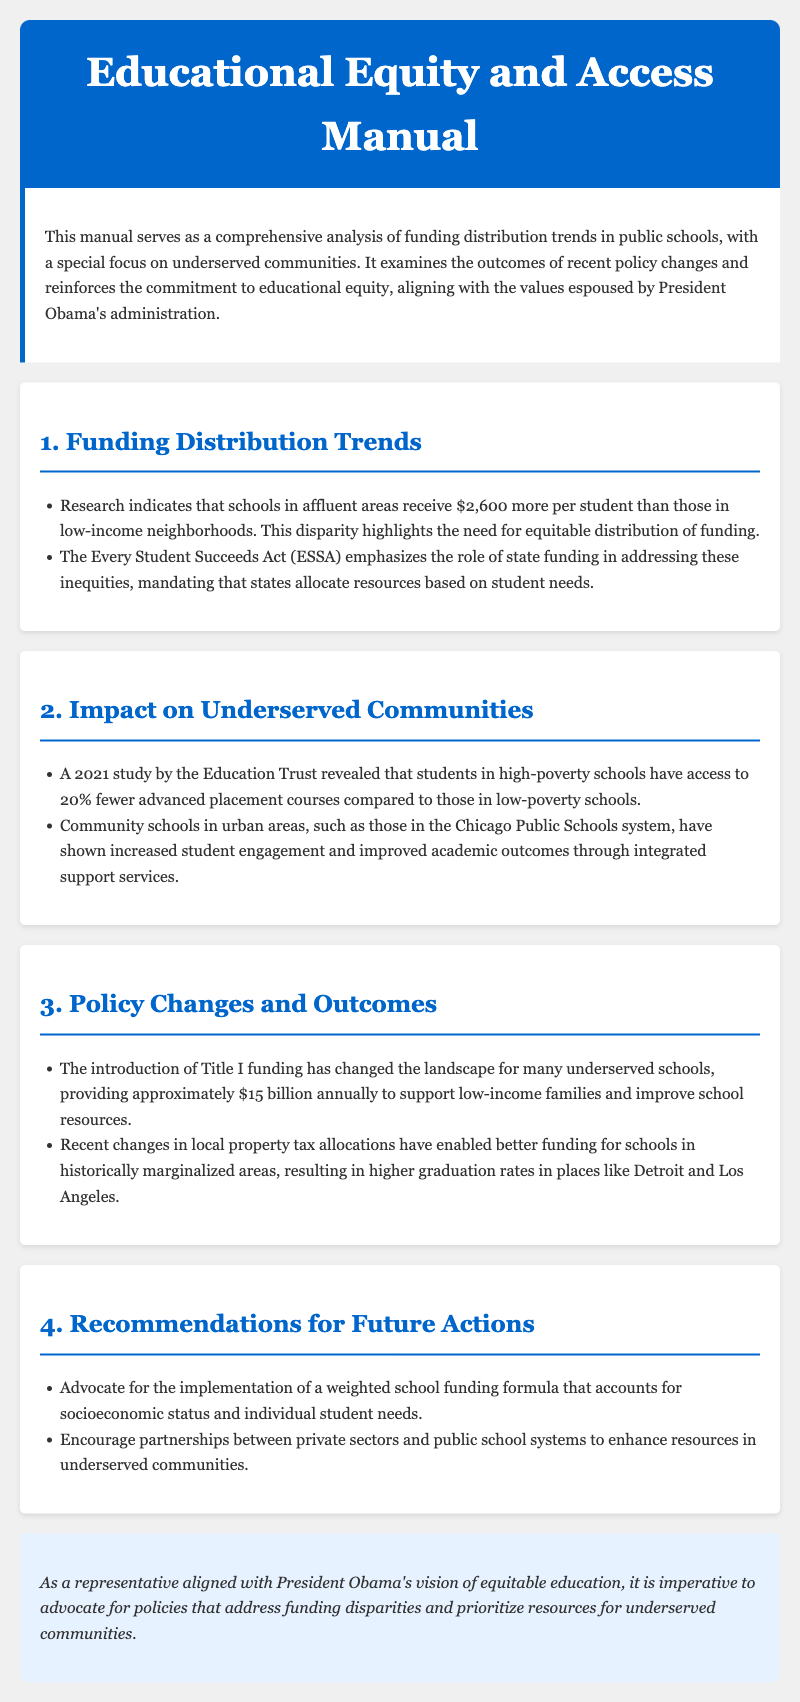What is the funding disparity per student in affluent areas? The document states that schools in affluent areas receive $2,600 more per student than those in low-income neighborhoods.
Answer: $2,600 What does ESSA emphasize? The Every Student Succeeds Act (ESSA) emphasizes the role of state funding in addressing inequities in education.
Answer: State funding What percentage fewer advanced placement courses do students in high-poverty schools have? A study revealed that students in high-poverty schools have access to 20% fewer advanced placement courses compared to those in low-poverty schools.
Answer: 20% How much does Title I funding provide annually? The document mentions that Title I funding provides approximately $15 billion annually to support low-income families and improve school resources.
Answer: $15 billion What notable city is mentioned regarding community schools improving academic outcomes? The document highlights the impact of community schools in urban areas, specifically in the Chicago Public Schools system.
Answer: Chicago What is a key recommendation for future actions regarding school funding? A key recommendation is to advocate for the implementation of a weighted school funding formula that accounts for socioeconomic status and individual student needs.
Answer: Weighted school funding formula How have recent changes in local property tax allocations affected schools? The document states that recent changes in local property tax allocations have enabled better funding for schools in historically marginalized areas.
Answer: Better funding What is the primary focus of this manual? The primary focus of the manual is on funding distribution trends in public schools, particularly regarding underserved communities.
Answer: Underserved communities What is the concluding emphasis of the document? The conclusion emphasizes advocating for policies that address funding disparities and prioritize resources for underserved communities.
Answer: Funding disparities 